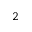Convert formula to latex. <formula><loc_0><loc_0><loc_500><loc_500>^ { 2 }</formula> 